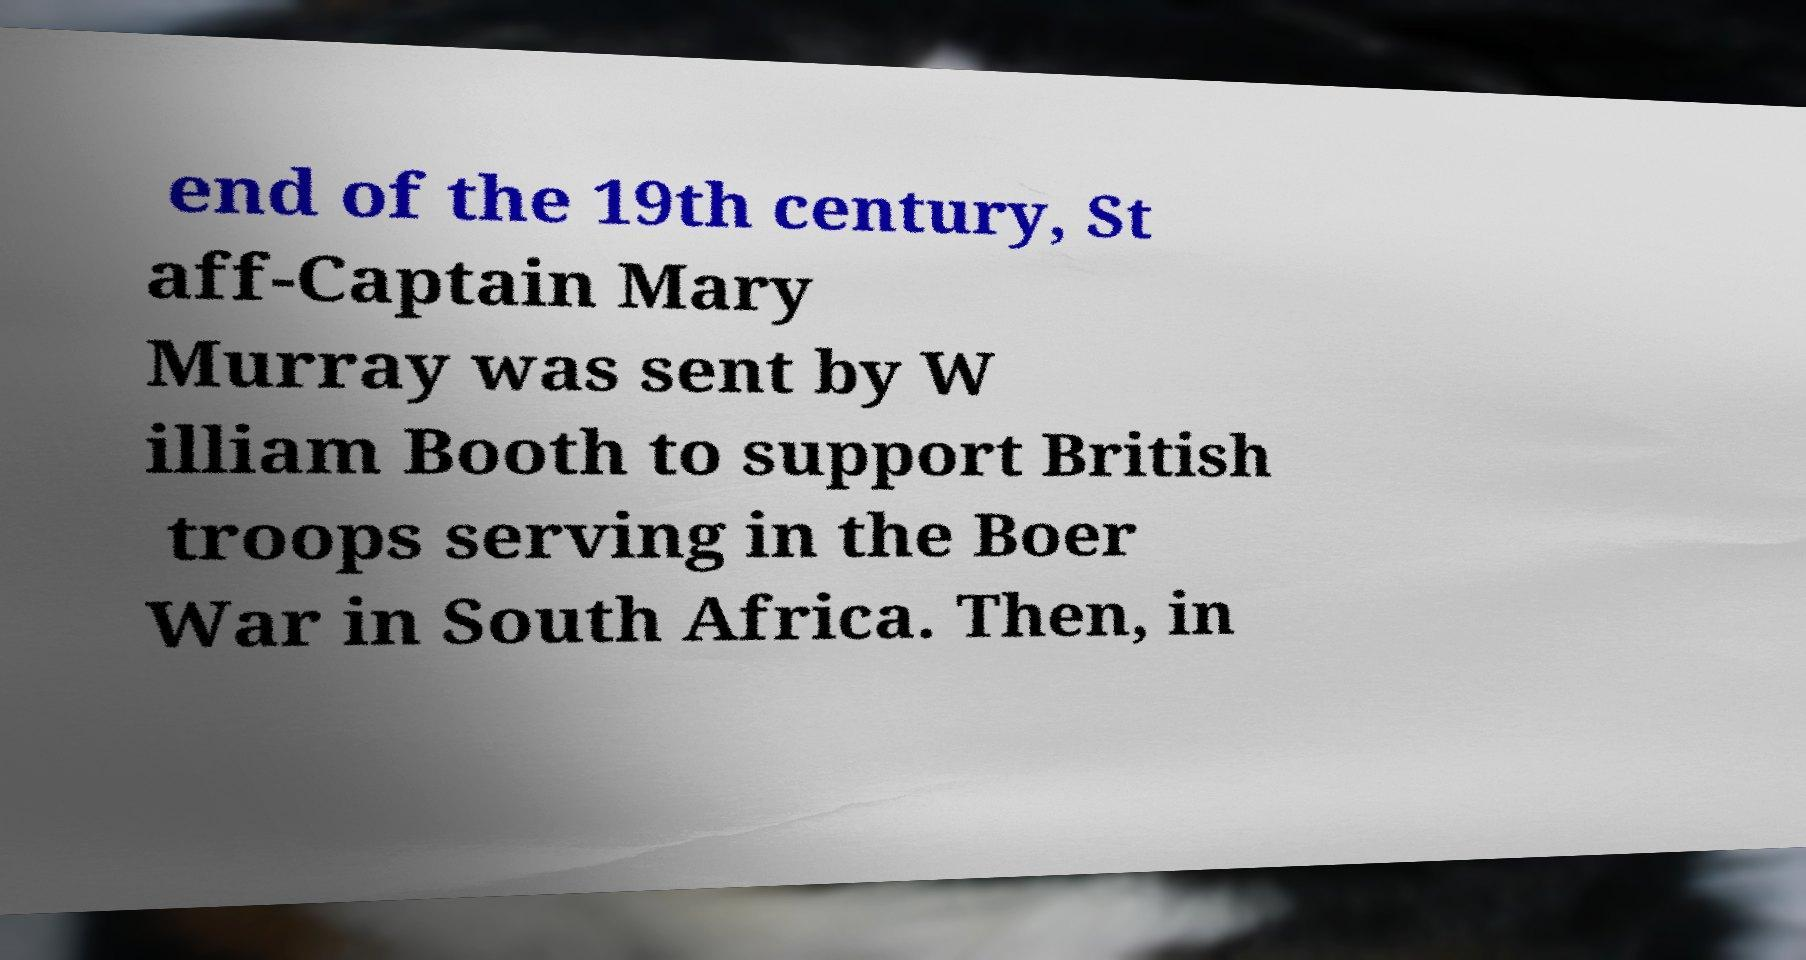What messages or text are displayed in this image? I need them in a readable, typed format. end of the 19th century, St aff-Captain Mary Murray was sent by W illiam Booth to support British troops serving in the Boer War in South Africa. Then, in 